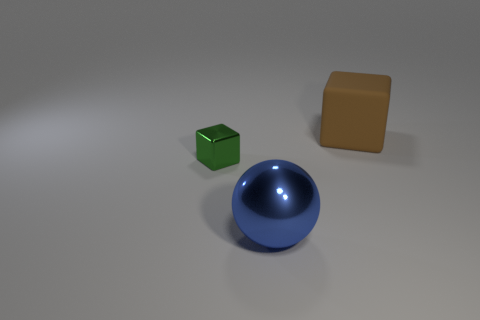Subtract all spheres. How many objects are left? 2 Add 1 large brown metallic blocks. How many objects exist? 4 Subtract 1 blue balls. How many objects are left? 2 Subtract 1 spheres. How many spheres are left? 0 Subtract all blue blocks. Subtract all cyan cylinders. How many blocks are left? 2 Subtract all blue balls. How many blue cubes are left? 0 Subtract all gray blocks. Subtract all small shiny objects. How many objects are left? 2 Add 2 large blue things. How many large blue things are left? 3 Add 3 tiny green shiny objects. How many tiny green shiny objects exist? 4 